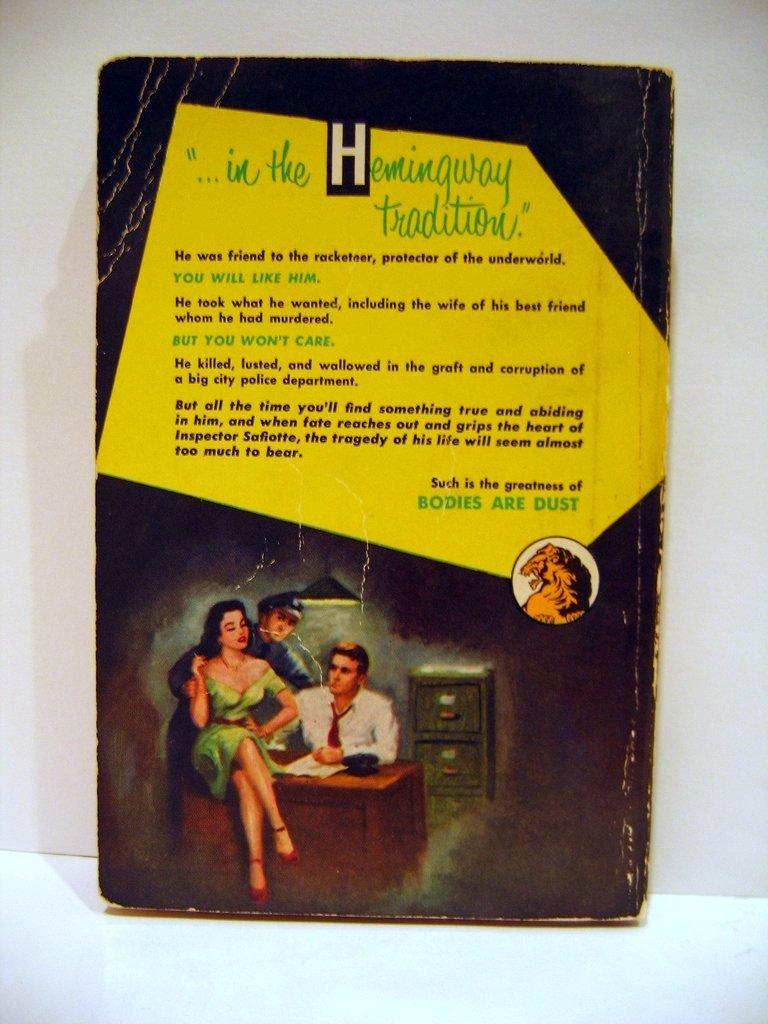<image>
Offer a succinct explanation of the picture presented. the cover of a book that says '...in the hemingway tradition' 